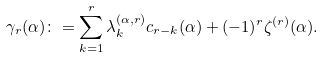<formula> <loc_0><loc_0><loc_500><loc_500>\gamma _ { r } ( \alpha ) \colon = \sum _ { k = 1 } ^ { r } \lambda _ { k } ^ { ( \alpha , r ) } c _ { r - k } ( \alpha ) + ( - 1 ) ^ { r } \zeta ^ { ( r ) } ( \alpha ) .</formula> 